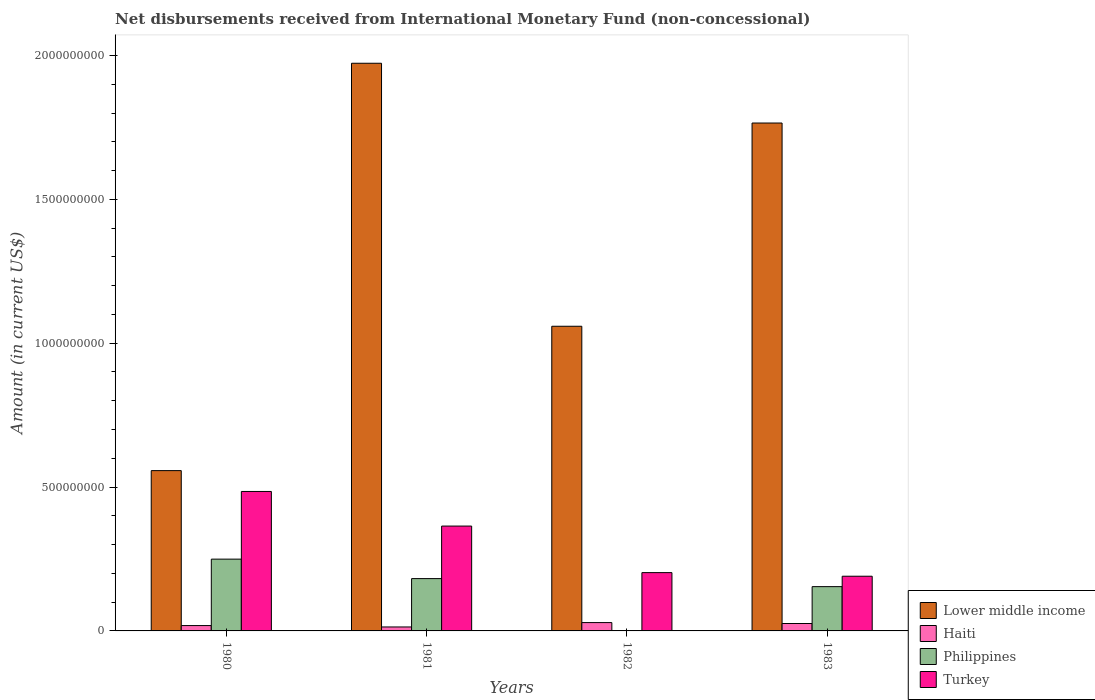How many different coloured bars are there?
Keep it short and to the point. 4. How many groups of bars are there?
Your answer should be compact. 4. Are the number of bars on each tick of the X-axis equal?
Give a very brief answer. No. How many bars are there on the 3rd tick from the right?
Offer a very short reply. 4. What is the label of the 4th group of bars from the left?
Provide a succinct answer. 1983. What is the amount of disbursements received from International Monetary Fund in Philippines in 1982?
Provide a succinct answer. 0. Across all years, what is the maximum amount of disbursements received from International Monetary Fund in Haiti?
Provide a short and direct response. 2.90e+07. Across all years, what is the minimum amount of disbursements received from International Monetary Fund in Lower middle income?
Your answer should be very brief. 5.57e+08. In which year was the amount of disbursements received from International Monetary Fund in Haiti maximum?
Ensure brevity in your answer.  1982. What is the total amount of disbursements received from International Monetary Fund in Lower middle income in the graph?
Keep it short and to the point. 5.35e+09. What is the difference between the amount of disbursements received from International Monetary Fund in Lower middle income in 1980 and that in 1982?
Offer a terse response. -5.02e+08. What is the difference between the amount of disbursements received from International Monetary Fund in Philippines in 1982 and the amount of disbursements received from International Monetary Fund in Lower middle income in 1983?
Your answer should be very brief. -1.77e+09. What is the average amount of disbursements received from International Monetary Fund in Philippines per year?
Your answer should be very brief. 1.46e+08. In the year 1980, what is the difference between the amount of disbursements received from International Monetary Fund in Lower middle income and amount of disbursements received from International Monetary Fund in Philippines?
Provide a succinct answer. 3.08e+08. In how many years, is the amount of disbursements received from International Monetary Fund in Turkey greater than 1500000000 US$?
Keep it short and to the point. 0. What is the ratio of the amount of disbursements received from International Monetary Fund in Turkey in 1982 to that in 1983?
Provide a succinct answer. 1.07. Is the amount of disbursements received from International Monetary Fund in Lower middle income in 1980 less than that in 1982?
Your answer should be very brief. Yes. What is the difference between the highest and the second highest amount of disbursements received from International Monetary Fund in Turkey?
Your answer should be very brief. 1.20e+08. What is the difference between the highest and the lowest amount of disbursements received from International Monetary Fund in Philippines?
Make the answer very short. 2.50e+08. Is it the case that in every year, the sum of the amount of disbursements received from International Monetary Fund in Turkey and amount of disbursements received from International Monetary Fund in Haiti is greater than the sum of amount of disbursements received from International Monetary Fund in Philippines and amount of disbursements received from International Monetary Fund in Lower middle income?
Your response must be concise. No. Is it the case that in every year, the sum of the amount of disbursements received from International Monetary Fund in Philippines and amount of disbursements received from International Monetary Fund in Haiti is greater than the amount of disbursements received from International Monetary Fund in Lower middle income?
Give a very brief answer. No. Are all the bars in the graph horizontal?
Your answer should be compact. No. How many years are there in the graph?
Give a very brief answer. 4. Are the values on the major ticks of Y-axis written in scientific E-notation?
Your response must be concise. No. Does the graph contain any zero values?
Your response must be concise. Yes. Does the graph contain grids?
Give a very brief answer. No. How many legend labels are there?
Give a very brief answer. 4. How are the legend labels stacked?
Your response must be concise. Vertical. What is the title of the graph?
Keep it short and to the point. Net disbursements received from International Monetary Fund (non-concessional). Does "Sudan" appear as one of the legend labels in the graph?
Provide a short and direct response. No. What is the Amount (in current US$) in Lower middle income in 1980?
Keep it short and to the point. 5.57e+08. What is the Amount (in current US$) in Haiti in 1980?
Give a very brief answer. 1.86e+07. What is the Amount (in current US$) of Philippines in 1980?
Your answer should be very brief. 2.50e+08. What is the Amount (in current US$) of Turkey in 1980?
Your answer should be very brief. 4.85e+08. What is the Amount (in current US$) of Lower middle income in 1981?
Offer a very short reply. 1.97e+09. What is the Amount (in current US$) in Haiti in 1981?
Give a very brief answer. 1.38e+07. What is the Amount (in current US$) of Philippines in 1981?
Give a very brief answer. 1.82e+08. What is the Amount (in current US$) in Turkey in 1981?
Provide a short and direct response. 3.64e+08. What is the Amount (in current US$) of Lower middle income in 1982?
Ensure brevity in your answer.  1.06e+09. What is the Amount (in current US$) of Haiti in 1982?
Your answer should be very brief. 2.90e+07. What is the Amount (in current US$) in Philippines in 1982?
Ensure brevity in your answer.  0. What is the Amount (in current US$) of Turkey in 1982?
Offer a very short reply. 2.03e+08. What is the Amount (in current US$) in Lower middle income in 1983?
Your answer should be very brief. 1.77e+09. What is the Amount (in current US$) of Haiti in 1983?
Your response must be concise. 2.58e+07. What is the Amount (in current US$) in Philippines in 1983?
Ensure brevity in your answer.  1.54e+08. What is the Amount (in current US$) in Turkey in 1983?
Your answer should be compact. 1.90e+08. Across all years, what is the maximum Amount (in current US$) of Lower middle income?
Keep it short and to the point. 1.97e+09. Across all years, what is the maximum Amount (in current US$) in Haiti?
Your answer should be very brief. 2.90e+07. Across all years, what is the maximum Amount (in current US$) of Philippines?
Offer a very short reply. 2.50e+08. Across all years, what is the maximum Amount (in current US$) in Turkey?
Give a very brief answer. 4.85e+08. Across all years, what is the minimum Amount (in current US$) in Lower middle income?
Make the answer very short. 5.57e+08. Across all years, what is the minimum Amount (in current US$) in Haiti?
Your answer should be very brief. 1.38e+07. Across all years, what is the minimum Amount (in current US$) in Philippines?
Your response must be concise. 0. Across all years, what is the minimum Amount (in current US$) of Turkey?
Make the answer very short. 1.90e+08. What is the total Amount (in current US$) of Lower middle income in the graph?
Give a very brief answer. 5.35e+09. What is the total Amount (in current US$) in Haiti in the graph?
Offer a very short reply. 8.71e+07. What is the total Amount (in current US$) in Philippines in the graph?
Provide a short and direct response. 5.85e+08. What is the total Amount (in current US$) of Turkey in the graph?
Give a very brief answer. 1.24e+09. What is the difference between the Amount (in current US$) of Lower middle income in 1980 and that in 1981?
Your response must be concise. -1.42e+09. What is the difference between the Amount (in current US$) of Haiti in 1980 and that in 1981?
Offer a terse response. 4.82e+06. What is the difference between the Amount (in current US$) in Philippines in 1980 and that in 1981?
Provide a short and direct response. 6.77e+07. What is the difference between the Amount (in current US$) in Turkey in 1980 and that in 1981?
Provide a succinct answer. 1.20e+08. What is the difference between the Amount (in current US$) of Lower middle income in 1980 and that in 1982?
Your response must be concise. -5.02e+08. What is the difference between the Amount (in current US$) in Haiti in 1980 and that in 1982?
Keep it short and to the point. -1.04e+07. What is the difference between the Amount (in current US$) of Turkey in 1980 and that in 1982?
Offer a very short reply. 2.82e+08. What is the difference between the Amount (in current US$) in Lower middle income in 1980 and that in 1983?
Provide a succinct answer. -1.21e+09. What is the difference between the Amount (in current US$) of Haiti in 1980 and that in 1983?
Your response must be concise. -7.17e+06. What is the difference between the Amount (in current US$) in Philippines in 1980 and that in 1983?
Provide a succinct answer. 9.56e+07. What is the difference between the Amount (in current US$) of Turkey in 1980 and that in 1983?
Your answer should be compact. 2.95e+08. What is the difference between the Amount (in current US$) in Lower middle income in 1981 and that in 1982?
Offer a very short reply. 9.14e+08. What is the difference between the Amount (in current US$) of Haiti in 1981 and that in 1982?
Provide a short and direct response. -1.52e+07. What is the difference between the Amount (in current US$) of Turkey in 1981 and that in 1982?
Offer a very short reply. 1.62e+08. What is the difference between the Amount (in current US$) of Lower middle income in 1981 and that in 1983?
Provide a short and direct response. 2.08e+08. What is the difference between the Amount (in current US$) of Haiti in 1981 and that in 1983?
Provide a short and direct response. -1.20e+07. What is the difference between the Amount (in current US$) in Philippines in 1981 and that in 1983?
Your response must be concise. 2.79e+07. What is the difference between the Amount (in current US$) of Turkey in 1981 and that in 1983?
Ensure brevity in your answer.  1.74e+08. What is the difference between the Amount (in current US$) of Lower middle income in 1982 and that in 1983?
Ensure brevity in your answer.  -7.06e+08. What is the difference between the Amount (in current US$) in Haiti in 1982 and that in 1983?
Make the answer very short. 3.20e+06. What is the difference between the Amount (in current US$) in Turkey in 1982 and that in 1983?
Your response must be concise. 1.25e+07. What is the difference between the Amount (in current US$) in Lower middle income in 1980 and the Amount (in current US$) in Haiti in 1981?
Keep it short and to the point. 5.43e+08. What is the difference between the Amount (in current US$) in Lower middle income in 1980 and the Amount (in current US$) in Philippines in 1981?
Your answer should be compact. 3.75e+08. What is the difference between the Amount (in current US$) in Lower middle income in 1980 and the Amount (in current US$) in Turkey in 1981?
Offer a terse response. 1.93e+08. What is the difference between the Amount (in current US$) in Haiti in 1980 and the Amount (in current US$) in Philippines in 1981?
Give a very brief answer. -1.63e+08. What is the difference between the Amount (in current US$) in Haiti in 1980 and the Amount (in current US$) in Turkey in 1981?
Ensure brevity in your answer.  -3.46e+08. What is the difference between the Amount (in current US$) of Philippines in 1980 and the Amount (in current US$) of Turkey in 1981?
Ensure brevity in your answer.  -1.15e+08. What is the difference between the Amount (in current US$) of Lower middle income in 1980 and the Amount (in current US$) of Haiti in 1982?
Give a very brief answer. 5.28e+08. What is the difference between the Amount (in current US$) in Lower middle income in 1980 and the Amount (in current US$) in Turkey in 1982?
Ensure brevity in your answer.  3.54e+08. What is the difference between the Amount (in current US$) in Haiti in 1980 and the Amount (in current US$) in Turkey in 1982?
Provide a short and direct response. -1.84e+08. What is the difference between the Amount (in current US$) in Philippines in 1980 and the Amount (in current US$) in Turkey in 1982?
Your answer should be compact. 4.69e+07. What is the difference between the Amount (in current US$) in Lower middle income in 1980 and the Amount (in current US$) in Haiti in 1983?
Keep it short and to the point. 5.31e+08. What is the difference between the Amount (in current US$) in Lower middle income in 1980 and the Amount (in current US$) in Philippines in 1983?
Ensure brevity in your answer.  4.03e+08. What is the difference between the Amount (in current US$) of Lower middle income in 1980 and the Amount (in current US$) of Turkey in 1983?
Provide a succinct answer. 3.67e+08. What is the difference between the Amount (in current US$) of Haiti in 1980 and the Amount (in current US$) of Philippines in 1983?
Provide a short and direct response. -1.35e+08. What is the difference between the Amount (in current US$) in Haiti in 1980 and the Amount (in current US$) in Turkey in 1983?
Give a very brief answer. -1.72e+08. What is the difference between the Amount (in current US$) of Philippines in 1980 and the Amount (in current US$) of Turkey in 1983?
Your answer should be very brief. 5.94e+07. What is the difference between the Amount (in current US$) in Lower middle income in 1981 and the Amount (in current US$) in Haiti in 1982?
Provide a succinct answer. 1.94e+09. What is the difference between the Amount (in current US$) of Lower middle income in 1981 and the Amount (in current US$) of Turkey in 1982?
Make the answer very short. 1.77e+09. What is the difference between the Amount (in current US$) in Haiti in 1981 and the Amount (in current US$) in Turkey in 1982?
Keep it short and to the point. -1.89e+08. What is the difference between the Amount (in current US$) of Philippines in 1981 and the Amount (in current US$) of Turkey in 1982?
Give a very brief answer. -2.08e+07. What is the difference between the Amount (in current US$) in Lower middle income in 1981 and the Amount (in current US$) in Haiti in 1983?
Keep it short and to the point. 1.95e+09. What is the difference between the Amount (in current US$) in Lower middle income in 1981 and the Amount (in current US$) in Philippines in 1983?
Make the answer very short. 1.82e+09. What is the difference between the Amount (in current US$) in Lower middle income in 1981 and the Amount (in current US$) in Turkey in 1983?
Your answer should be very brief. 1.78e+09. What is the difference between the Amount (in current US$) of Haiti in 1981 and the Amount (in current US$) of Philippines in 1983?
Provide a short and direct response. -1.40e+08. What is the difference between the Amount (in current US$) in Haiti in 1981 and the Amount (in current US$) in Turkey in 1983?
Make the answer very short. -1.76e+08. What is the difference between the Amount (in current US$) of Philippines in 1981 and the Amount (in current US$) of Turkey in 1983?
Give a very brief answer. -8.26e+06. What is the difference between the Amount (in current US$) of Lower middle income in 1982 and the Amount (in current US$) of Haiti in 1983?
Your answer should be compact. 1.03e+09. What is the difference between the Amount (in current US$) in Lower middle income in 1982 and the Amount (in current US$) in Philippines in 1983?
Provide a short and direct response. 9.05e+08. What is the difference between the Amount (in current US$) in Lower middle income in 1982 and the Amount (in current US$) in Turkey in 1983?
Provide a short and direct response. 8.69e+08. What is the difference between the Amount (in current US$) in Haiti in 1982 and the Amount (in current US$) in Philippines in 1983?
Offer a terse response. -1.25e+08. What is the difference between the Amount (in current US$) of Haiti in 1982 and the Amount (in current US$) of Turkey in 1983?
Offer a very short reply. -1.61e+08. What is the average Amount (in current US$) of Lower middle income per year?
Your response must be concise. 1.34e+09. What is the average Amount (in current US$) of Haiti per year?
Give a very brief answer. 2.18e+07. What is the average Amount (in current US$) of Philippines per year?
Your answer should be very brief. 1.46e+08. What is the average Amount (in current US$) of Turkey per year?
Give a very brief answer. 3.10e+08. In the year 1980, what is the difference between the Amount (in current US$) in Lower middle income and Amount (in current US$) in Haiti?
Provide a short and direct response. 5.39e+08. In the year 1980, what is the difference between the Amount (in current US$) in Lower middle income and Amount (in current US$) in Philippines?
Provide a succinct answer. 3.08e+08. In the year 1980, what is the difference between the Amount (in current US$) in Lower middle income and Amount (in current US$) in Turkey?
Ensure brevity in your answer.  7.24e+07. In the year 1980, what is the difference between the Amount (in current US$) in Haiti and Amount (in current US$) in Philippines?
Make the answer very short. -2.31e+08. In the year 1980, what is the difference between the Amount (in current US$) in Haiti and Amount (in current US$) in Turkey?
Offer a very short reply. -4.66e+08. In the year 1980, what is the difference between the Amount (in current US$) of Philippines and Amount (in current US$) of Turkey?
Your answer should be compact. -2.35e+08. In the year 1981, what is the difference between the Amount (in current US$) of Lower middle income and Amount (in current US$) of Haiti?
Your answer should be compact. 1.96e+09. In the year 1981, what is the difference between the Amount (in current US$) in Lower middle income and Amount (in current US$) in Philippines?
Provide a succinct answer. 1.79e+09. In the year 1981, what is the difference between the Amount (in current US$) of Lower middle income and Amount (in current US$) of Turkey?
Give a very brief answer. 1.61e+09. In the year 1981, what is the difference between the Amount (in current US$) of Haiti and Amount (in current US$) of Philippines?
Provide a succinct answer. -1.68e+08. In the year 1981, what is the difference between the Amount (in current US$) in Haiti and Amount (in current US$) in Turkey?
Make the answer very short. -3.51e+08. In the year 1981, what is the difference between the Amount (in current US$) of Philippines and Amount (in current US$) of Turkey?
Provide a short and direct response. -1.83e+08. In the year 1982, what is the difference between the Amount (in current US$) in Lower middle income and Amount (in current US$) in Haiti?
Make the answer very short. 1.03e+09. In the year 1982, what is the difference between the Amount (in current US$) in Lower middle income and Amount (in current US$) in Turkey?
Provide a succinct answer. 8.56e+08. In the year 1982, what is the difference between the Amount (in current US$) in Haiti and Amount (in current US$) in Turkey?
Provide a short and direct response. -1.74e+08. In the year 1983, what is the difference between the Amount (in current US$) of Lower middle income and Amount (in current US$) of Haiti?
Give a very brief answer. 1.74e+09. In the year 1983, what is the difference between the Amount (in current US$) in Lower middle income and Amount (in current US$) in Philippines?
Give a very brief answer. 1.61e+09. In the year 1983, what is the difference between the Amount (in current US$) of Lower middle income and Amount (in current US$) of Turkey?
Ensure brevity in your answer.  1.58e+09. In the year 1983, what is the difference between the Amount (in current US$) of Haiti and Amount (in current US$) of Philippines?
Ensure brevity in your answer.  -1.28e+08. In the year 1983, what is the difference between the Amount (in current US$) in Haiti and Amount (in current US$) in Turkey?
Make the answer very short. -1.64e+08. In the year 1983, what is the difference between the Amount (in current US$) in Philippines and Amount (in current US$) in Turkey?
Your answer should be compact. -3.62e+07. What is the ratio of the Amount (in current US$) in Lower middle income in 1980 to that in 1981?
Offer a terse response. 0.28. What is the ratio of the Amount (in current US$) in Haiti in 1980 to that in 1981?
Make the answer very short. 1.35. What is the ratio of the Amount (in current US$) of Philippines in 1980 to that in 1981?
Make the answer very short. 1.37. What is the ratio of the Amount (in current US$) in Turkey in 1980 to that in 1981?
Your answer should be compact. 1.33. What is the ratio of the Amount (in current US$) in Lower middle income in 1980 to that in 1982?
Your answer should be very brief. 0.53. What is the ratio of the Amount (in current US$) in Haiti in 1980 to that in 1982?
Provide a short and direct response. 0.64. What is the ratio of the Amount (in current US$) of Turkey in 1980 to that in 1982?
Ensure brevity in your answer.  2.39. What is the ratio of the Amount (in current US$) in Lower middle income in 1980 to that in 1983?
Offer a terse response. 0.32. What is the ratio of the Amount (in current US$) of Haiti in 1980 to that in 1983?
Your answer should be very brief. 0.72. What is the ratio of the Amount (in current US$) of Philippines in 1980 to that in 1983?
Your answer should be compact. 1.62. What is the ratio of the Amount (in current US$) in Turkey in 1980 to that in 1983?
Give a very brief answer. 2.55. What is the ratio of the Amount (in current US$) of Lower middle income in 1981 to that in 1982?
Your answer should be very brief. 1.86. What is the ratio of the Amount (in current US$) in Haiti in 1981 to that in 1982?
Give a very brief answer. 0.48. What is the ratio of the Amount (in current US$) of Turkey in 1981 to that in 1982?
Your response must be concise. 1.8. What is the ratio of the Amount (in current US$) in Lower middle income in 1981 to that in 1983?
Your response must be concise. 1.12. What is the ratio of the Amount (in current US$) in Haiti in 1981 to that in 1983?
Make the answer very short. 0.53. What is the ratio of the Amount (in current US$) in Philippines in 1981 to that in 1983?
Offer a very short reply. 1.18. What is the ratio of the Amount (in current US$) in Turkey in 1981 to that in 1983?
Provide a short and direct response. 1.92. What is the ratio of the Amount (in current US$) of Lower middle income in 1982 to that in 1983?
Keep it short and to the point. 0.6. What is the ratio of the Amount (in current US$) in Haiti in 1982 to that in 1983?
Your answer should be very brief. 1.12. What is the ratio of the Amount (in current US$) in Turkey in 1982 to that in 1983?
Your answer should be very brief. 1.07. What is the difference between the highest and the second highest Amount (in current US$) of Lower middle income?
Your answer should be compact. 2.08e+08. What is the difference between the highest and the second highest Amount (in current US$) in Haiti?
Give a very brief answer. 3.20e+06. What is the difference between the highest and the second highest Amount (in current US$) of Philippines?
Provide a short and direct response. 6.77e+07. What is the difference between the highest and the second highest Amount (in current US$) in Turkey?
Make the answer very short. 1.20e+08. What is the difference between the highest and the lowest Amount (in current US$) of Lower middle income?
Ensure brevity in your answer.  1.42e+09. What is the difference between the highest and the lowest Amount (in current US$) of Haiti?
Your answer should be very brief. 1.52e+07. What is the difference between the highest and the lowest Amount (in current US$) in Philippines?
Your answer should be compact. 2.50e+08. What is the difference between the highest and the lowest Amount (in current US$) in Turkey?
Offer a terse response. 2.95e+08. 